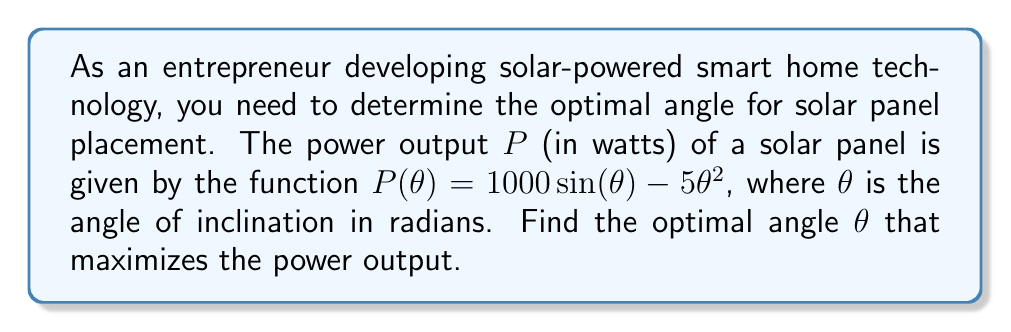Could you help me with this problem? To find the optimal angle that maximizes the power output, we need to follow these steps:

1. Find the derivative of the power function $P(\theta)$:
   $$\frac{dP}{d\theta} = 1000 \cos(\theta) - 10\theta$$

2. Set the derivative equal to zero to find the critical points:
   $$1000 \cos(\theta) - 10\theta = 0$$

3. Rearrange the equation:
   $$\cos(\theta) = \frac{\theta}{100}$$

4. This equation cannot be solved algebraically. We need to use numerical methods or a graphing calculator to find the solution. The solution is approximately $\theta \approx 0.7390$ radians.

5. To confirm this is a maximum, we can check the second derivative:
   $$\frac{d^2P}{d\theta^2} = -1000 \sin(\theta) - 10$$
   
   At $\theta \approx 0.7390$:
   $$\frac{d^2P}{d\theta^2} \approx -1000 \sin(0.7390) - 10 \approx -682.44 < 0$$

   Since the second derivative is negative, this confirms that $\theta \approx 0.7390$ is a local maximum.

6. Convert the angle from radians to degrees:
   $$0.7390 \text{ radians} \times \frac{180^\circ}{\pi} \approx 42.33^\circ$$

Therefore, the optimal angle for solar panel placement is approximately 42.33°.
Answer: 42.33° 